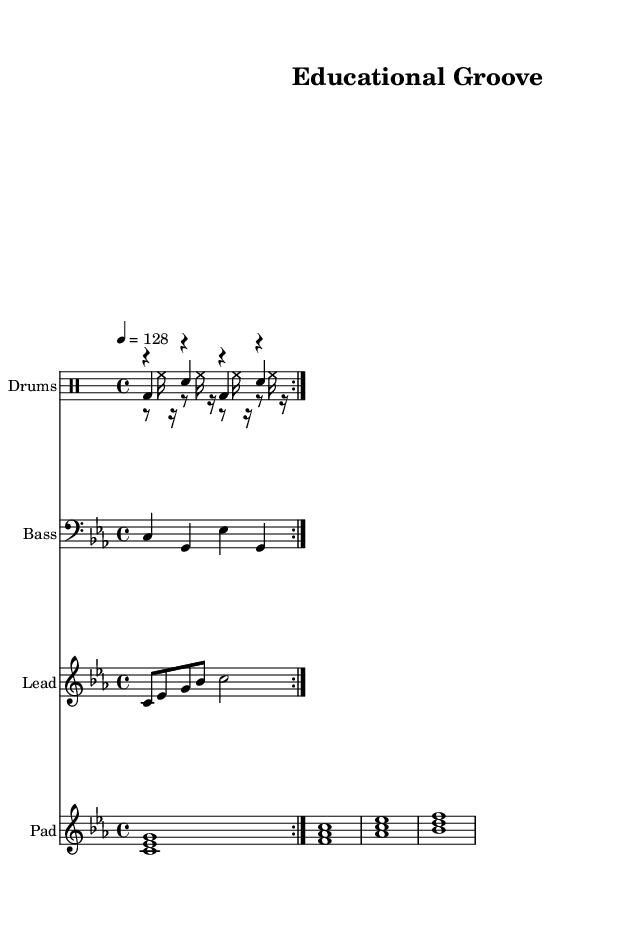What is the key signature of this music? The key signature is C minor, which has three flats: B flat, E flat, and A flat.
Answer: C minor What is the time signature of this music? The time signature shown in the sheet music is four beats per measure, as indicated by the "4/4" notation.
Answer: 4/4 What is the tempo marking for this piece? The tempo marking in the score states "4 = 128," meaning each quarter note is played at a speed of 128 beats per minute.
Answer: 128 How many times does the kick drum repeat in the pattern? The kick drum pattern is repeated two times, as indicated by the "repeat volta 2" instruction in the code.
Answer: 2 What is the highest pitch played in the lead synth? In the lead synth part, the highest pitch played is a C note two octaves above middle C, as indicated by c'' in the notation.
Answer: C'' How many distinct chords are played in the pad synth section? The pad synth section contains four distinct chords as represented by the four different voicings of notes shown in the measure.
Answer: 4 What type of drum is used for the snare in this piece? The snare drum is specifically mentioned in the drum mode notation as "sn," indicating the type of drum being played.
Answer: Snare 